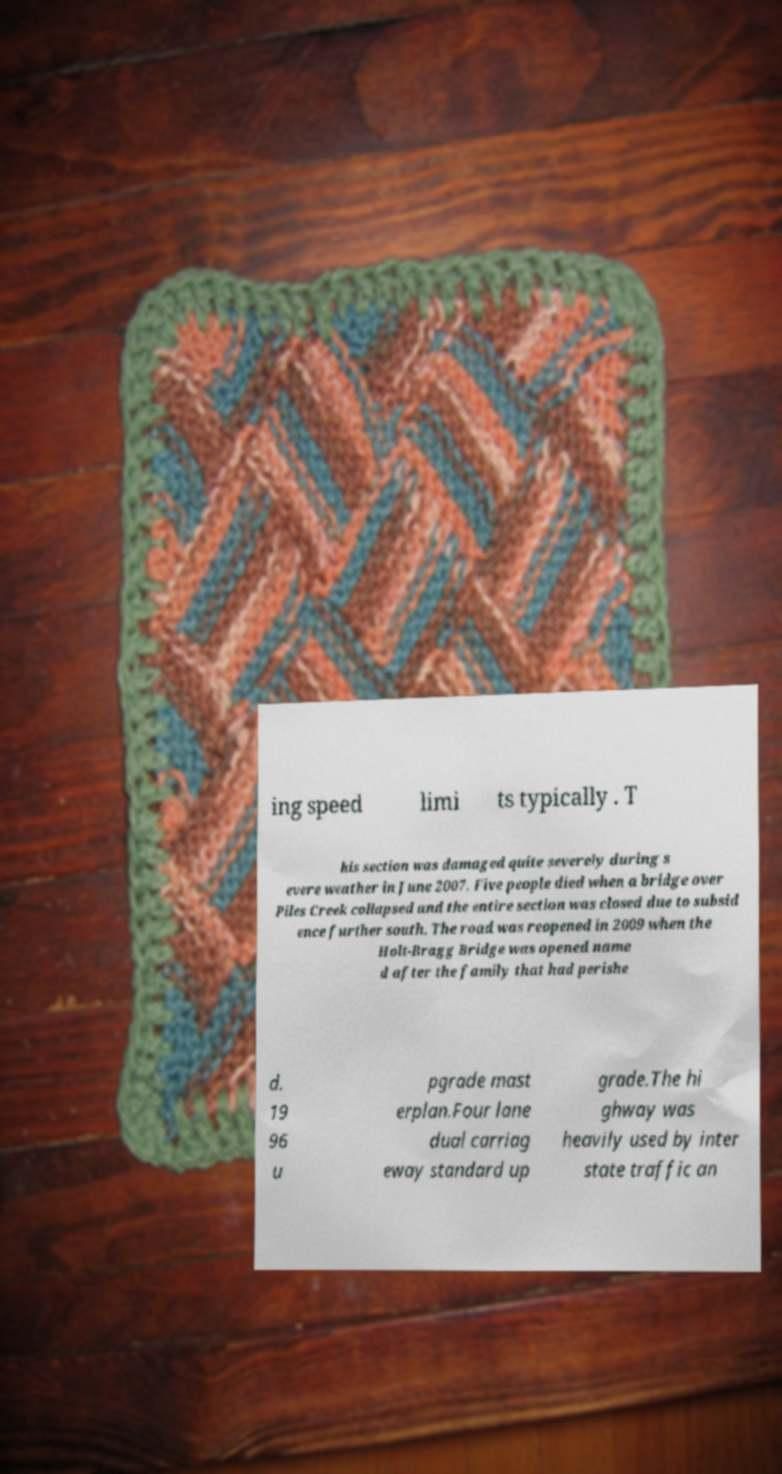What messages or text are displayed in this image? I need them in a readable, typed format. ing speed limi ts typically . T his section was damaged quite severely during s evere weather in June 2007. Five people died when a bridge over Piles Creek collapsed and the entire section was closed due to subsid ence further south. The road was reopened in 2009 when the Holt-Bragg Bridge was opened name d after the family that had perishe d. 19 96 u pgrade mast erplan.Four lane dual carriag eway standard up grade.The hi ghway was heavily used by inter state traffic an 